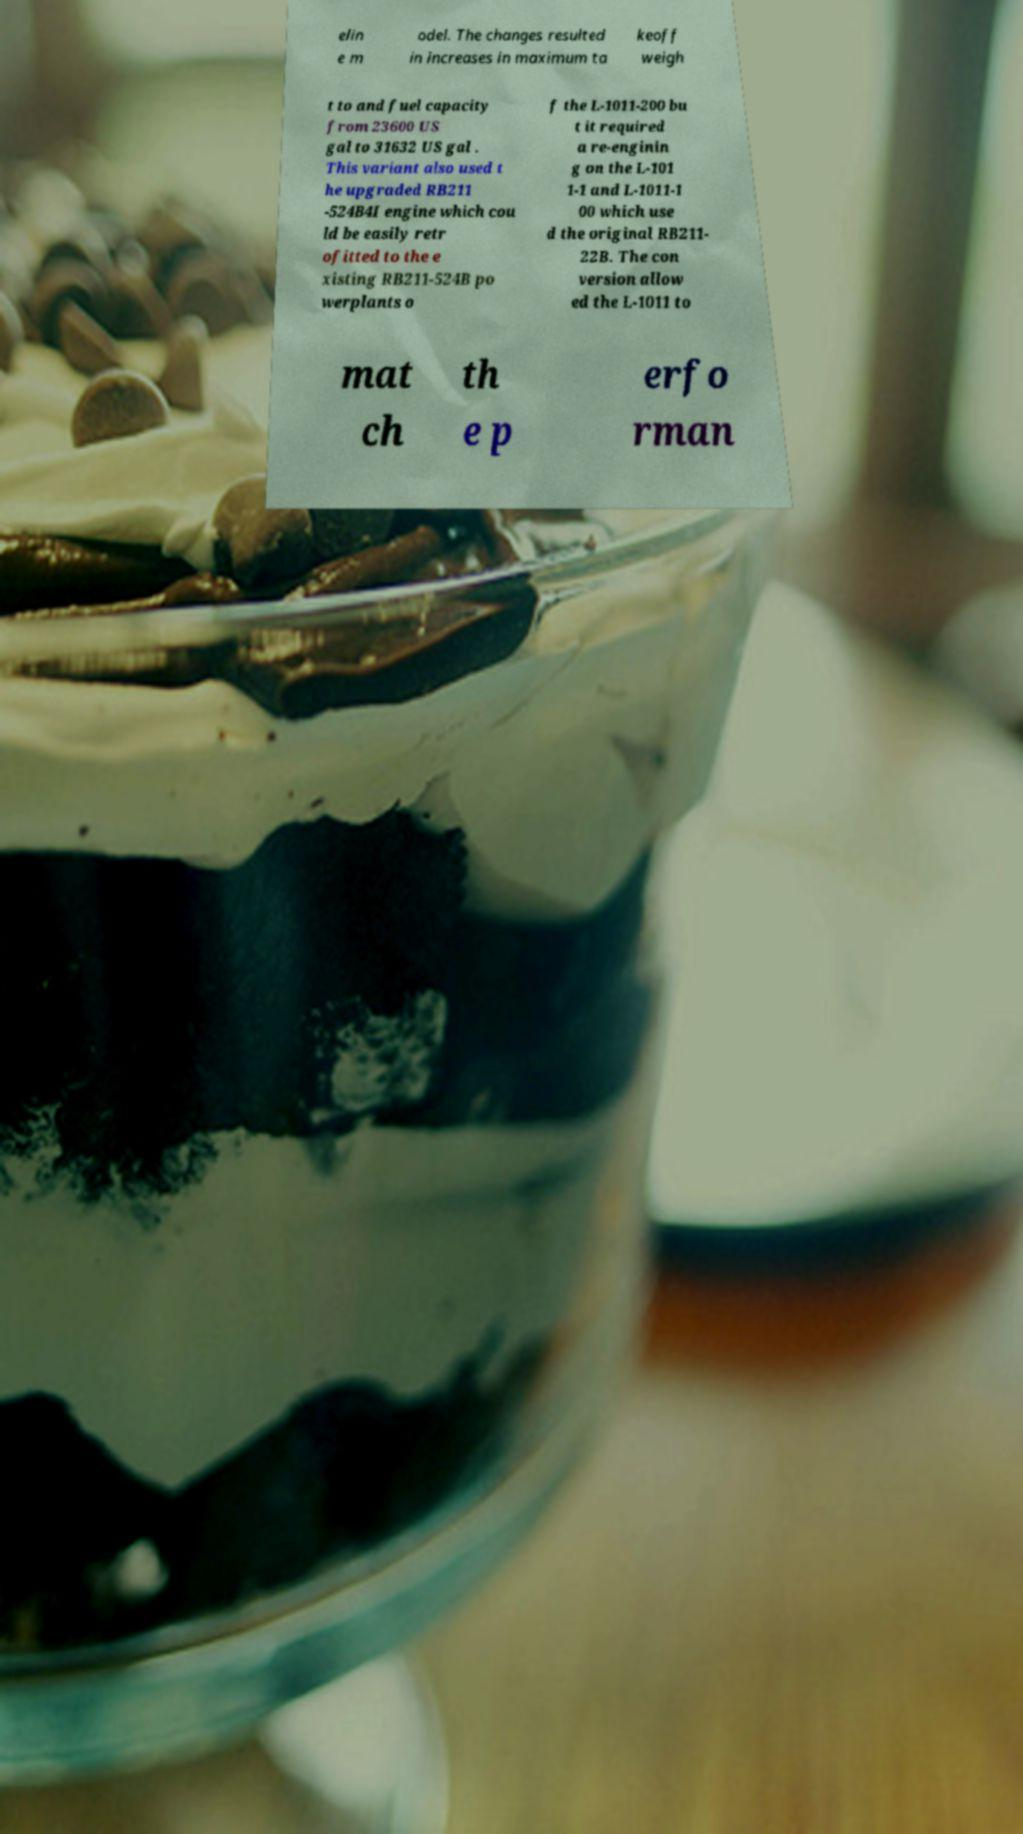There's text embedded in this image that I need extracted. Can you transcribe it verbatim? elin e m odel. The changes resulted in increases in maximum ta keoff weigh t to and fuel capacity from 23600 US gal to 31632 US gal . This variant also used t he upgraded RB211 -524B4I engine which cou ld be easily retr ofitted to the e xisting RB211-524B po werplants o f the L-1011-200 bu t it required a re-enginin g on the L-101 1-1 and L-1011-1 00 which use d the original RB211- 22B. The con version allow ed the L-1011 to mat ch th e p erfo rman 